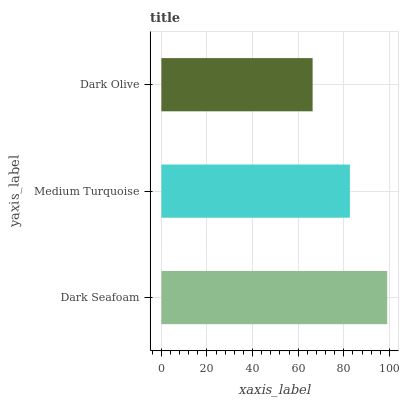Is Dark Olive the minimum?
Answer yes or no. Yes. Is Dark Seafoam the maximum?
Answer yes or no. Yes. Is Medium Turquoise the minimum?
Answer yes or no. No. Is Medium Turquoise the maximum?
Answer yes or no. No. Is Dark Seafoam greater than Medium Turquoise?
Answer yes or no. Yes. Is Medium Turquoise less than Dark Seafoam?
Answer yes or no. Yes. Is Medium Turquoise greater than Dark Seafoam?
Answer yes or no. No. Is Dark Seafoam less than Medium Turquoise?
Answer yes or no. No. Is Medium Turquoise the high median?
Answer yes or no. Yes. Is Medium Turquoise the low median?
Answer yes or no. Yes. Is Dark Seafoam the high median?
Answer yes or no. No. Is Dark Olive the low median?
Answer yes or no. No. 